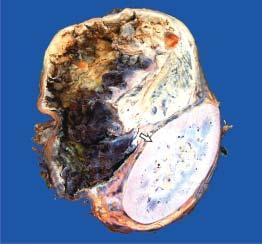what show dark brown, necrotic and haemorrhagic tumour?
Answer the question using a single word or phrase. Solid areas 